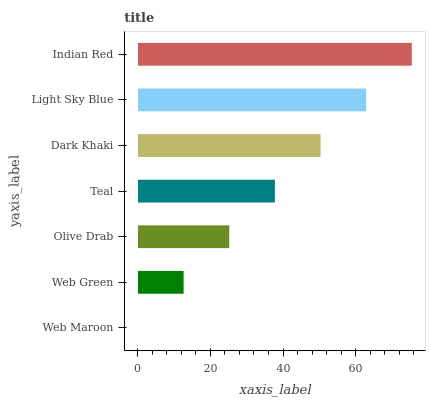Is Web Maroon the minimum?
Answer yes or no. Yes. Is Indian Red the maximum?
Answer yes or no. Yes. Is Web Green the minimum?
Answer yes or no. No. Is Web Green the maximum?
Answer yes or no. No. Is Web Green greater than Web Maroon?
Answer yes or no. Yes. Is Web Maroon less than Web Green?
Answer yes or no. Yes. Is Web Maroon greater than Web Green?
Answer yes or no. No. Is Web Green less than Web Maroon?
Answer yes or no. No. Is Teal the high median?
Answer yes or no. Yes. Is Teal the low median?
Answer yes or no. Yes. Is Indian Red the high median?
Answer yes or no. No. Is Dark Khaki the low median?
Answer yes or no. No. 